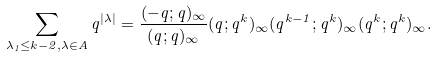Convert formula to latex. <formula><loc_0><loc_0><loc_500><loc_500>\sum _ { \lambda _ { 1 } \leq k - 2 , \lambda \in A } q ^ { | \lambda | } = \frac { ( - q ; q ) _ { \infty } } { ( q ; q ) _ { \infty } } ( q ; q ^ { k } ) _ { \infty } ( q ^ { k - 1 } ; q ^ { k } ) _ { \infty } ( q ^ { k } ; q ^ { k } ) _ { \infty } .</formula> 